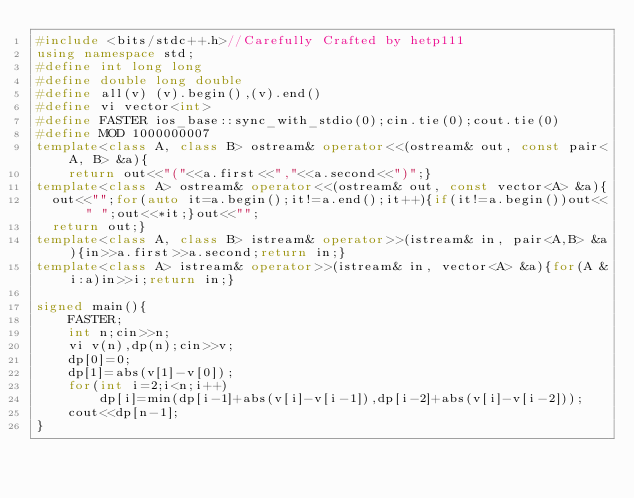<code> <loc_0><loc_0><loc_500><loc_500><_C++_>#include <bits/stdc++.h>//Carefully Crafted by hetp111
using namespace std;
#define int long long
#define double long double
#define all(v) (v).begin(),(v).end()
#define vi vector<int>
#define FASTER ios_base::sync_with_stdio(0);cin.tie(0);cout.tie(0)
#define MOD 1000000007
template<class A, class B> ostream& operator<<(ostream& out, const pair<A, B> &a){
    return out<<"("<<a.first<<","<<a.second<<")";}
template<class A> ostream& operator<<(ostream& out, const vector<A> &a){
	out<<"";for(auto it=a.begin();it!=a.end();it++){if(it!=a.begin())out<<" ";out<<*it;}out<<"";
	return out;}
template<class A, class B> istream& operator>>(istream& in, pair<A,B> &a){in>>a.first>>a.second;return in;}
template<class A> istream& operator>>(istream& in, vector<A> &a){for(A &i:a)in>>i;return in;}

signed main(){
    FASTER;
    int n;cin>>n;
    vi v(n),dp(n);cin>>v;
    dp[0]=0;
    dp[1]=abs(v[1]-v[0]);
    for(int i=2;i<n;i++)
        dp[i]=min(dp[i-1]+abs(v[i]-v[i-1]),dp[i-2]+abs(v[i]-v[i-2]));
    cout<<dp[n-1];
}
</code> 